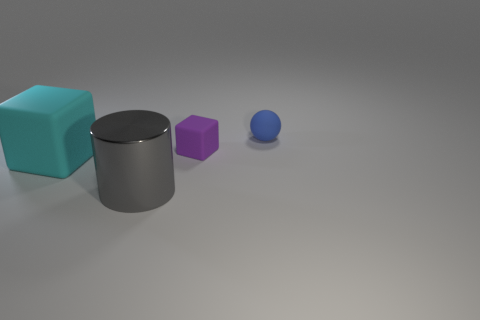Add 2 tiny blocks. How many objects exist? 6 Subtract all cylinders. How many objects are left? 3 Subtract all red cylinders. Subtract all purple spheres. How many cylinders are left? 1 Subtract all small purple matte objects. Subtract all matte spheres. How many objects are left? 2 Add 4 big metallic cylinders. How many big metallic cylinders are left? 5 Add 2 tiny purple blocks. How many tiny purple blocks exist? 3 Subtract 0 cyan cylinders. How many objects are left? 4 Subtract 1 cylinders. How many cylinders are left? 0 